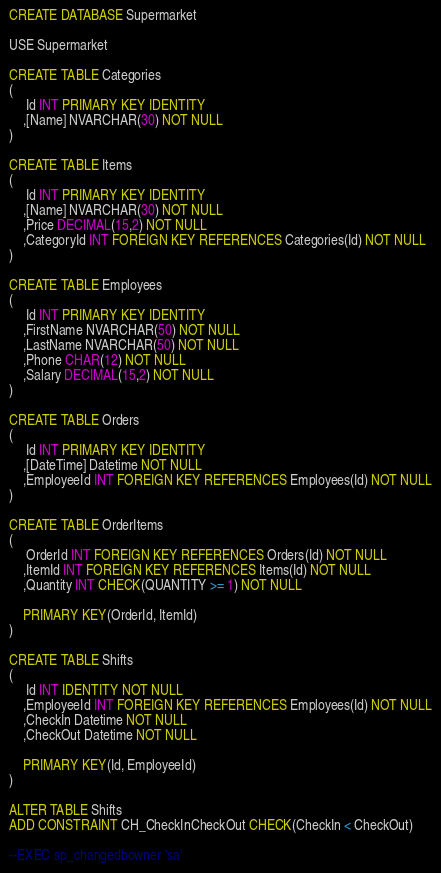Convert code to text. <code><loc_0><loc_0><loc_500><loc_500><_SQL_>
CREATE DATABASE Supermarket

USE Supermarket

CREATE TABLE Categories
(
	 Id INT PRIMARY KEY IDENTITY
	,[Name] NVARCHAR(30) NOT NULL
) 

CREATE TABLE Items
(
	 Id INT PRIMARY KEY IDENTITY
	,[Name] NVARCHAR(30) NOT NULL
	,Price DECIMAL(15,2) NOT NULL
	,CategoryId INT FOREIGN KEY REFERENCES Categories(Id) NOT NULL
)

CREATE TABLE Employees 
(
	 Id INT PRIMARY KEY IDENTITY
	,FirstName NVARCHAR(50) NOT NULL
	,LastName NVARCHAR(50) NOT NULL
	,Phone CHAR(12) NOT NULL
	,Salary DECIMAL(15,2) NOT NULL
)

CREATE TABLE Orders
(
	 Id INT PRIMARY KEY IDENTITY
	,[DateTime] Datetime NOT NULL
	,EmployeeId INT FOREIGN KEY REFERENCES Employees(Id) NOT NULL
)

CREATE TABLE OrderItems
(
	 OrderId INT FOREIGN KEY REFERENCES Orders(Id) NOT NULL
	,ItemId INT FOREIGN KEY REFERENCES Items(Id) NOT NULL 
	,Quantity INT CHECK(QUANTITY >= 1) NOT NULL

	PRIMARY KEY(OrderId, ItemId)
)

CREATE TABLE Shifts
(
	 Id INT IDENTITY NOT NULL
	,EmployeeId INT FOREIGN KEY REFERENCES Employees(Id) NOT NULL
	,CheckIn Datetime NOT NULL
	,CheckOut Datetime NOT NULL

	PRIMARY KEY(Id, EmployeeId)
)

ALTER TABLE Shifts
ADD CONSTRAINT CH_CheckInCheckOut CHECK(CheckIn < CheckOut)

--EXEC sp_changedbowner 'sa'</code> 